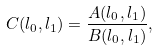Convert formula to latex. <formula><loc_0><loc_0><loc_500><loc_500>C ( l _ { 0 } , l _ { 1 } ) = \frac { A ( l _ { 0 } , l _ { 1 } ) } { B ( l _ { 0 } , l _ { 1 } ) } ,</formula> 